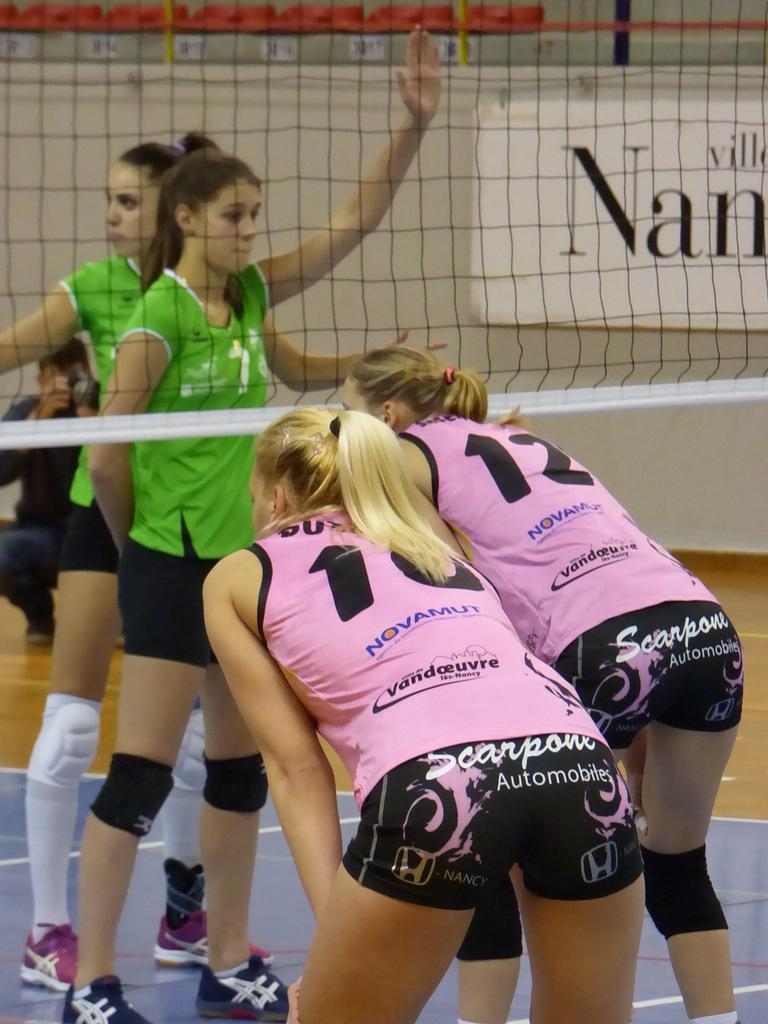<image>
Summarize the visual content of the image. A girls volleyball game with numbers 10 and 12 on the pink team. 